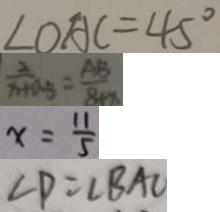Convert formula to latex. <formula><loc_0><loc_0><loc_500><loc_500>\angle O A C = 4 5 ^ { \circ } 
 \frac { 2 } { x + 0 . 5 } = \frac { A B } { 8 + x } 
 x = \frac { 1 1 } { 5 } 
 \angle P = \angle B A C</formula> 